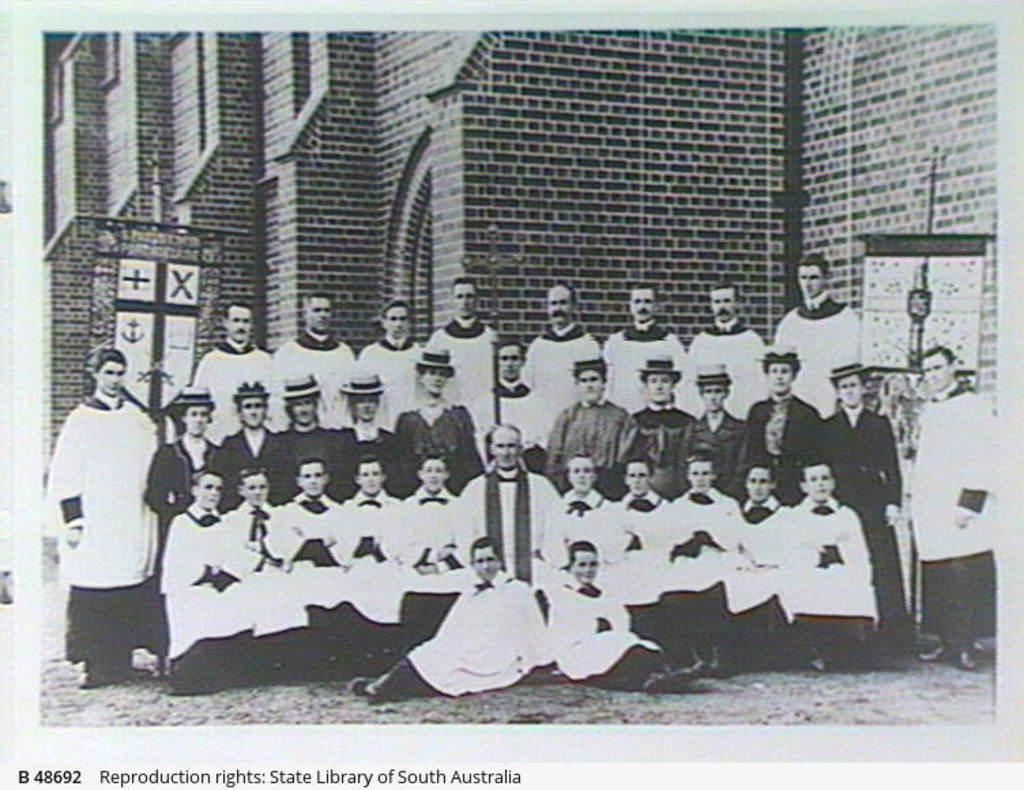What is happening in the foreground of the image? There is a crowd in the foreground of the image. What are the people in the crowd doing? The crowd is posing for a camera. What can be seen in the background of the image? There is a building in the background of the image. What type of music is being played in the bedroom in the image? There is no bedroom or music present in the image; it features a crowd posing for a camera in front of a building. 